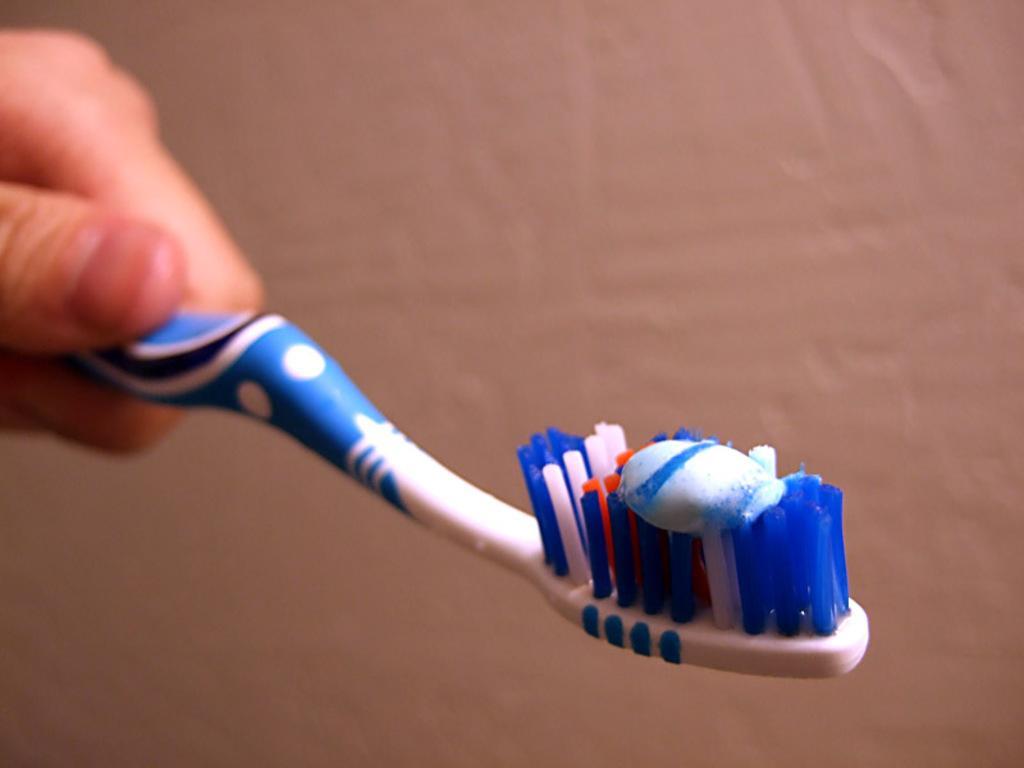How would you summarize this image in a sentence or two? In this image we can see the hand of a person holding a brush. Here we can see the toothpaste on the brush. 